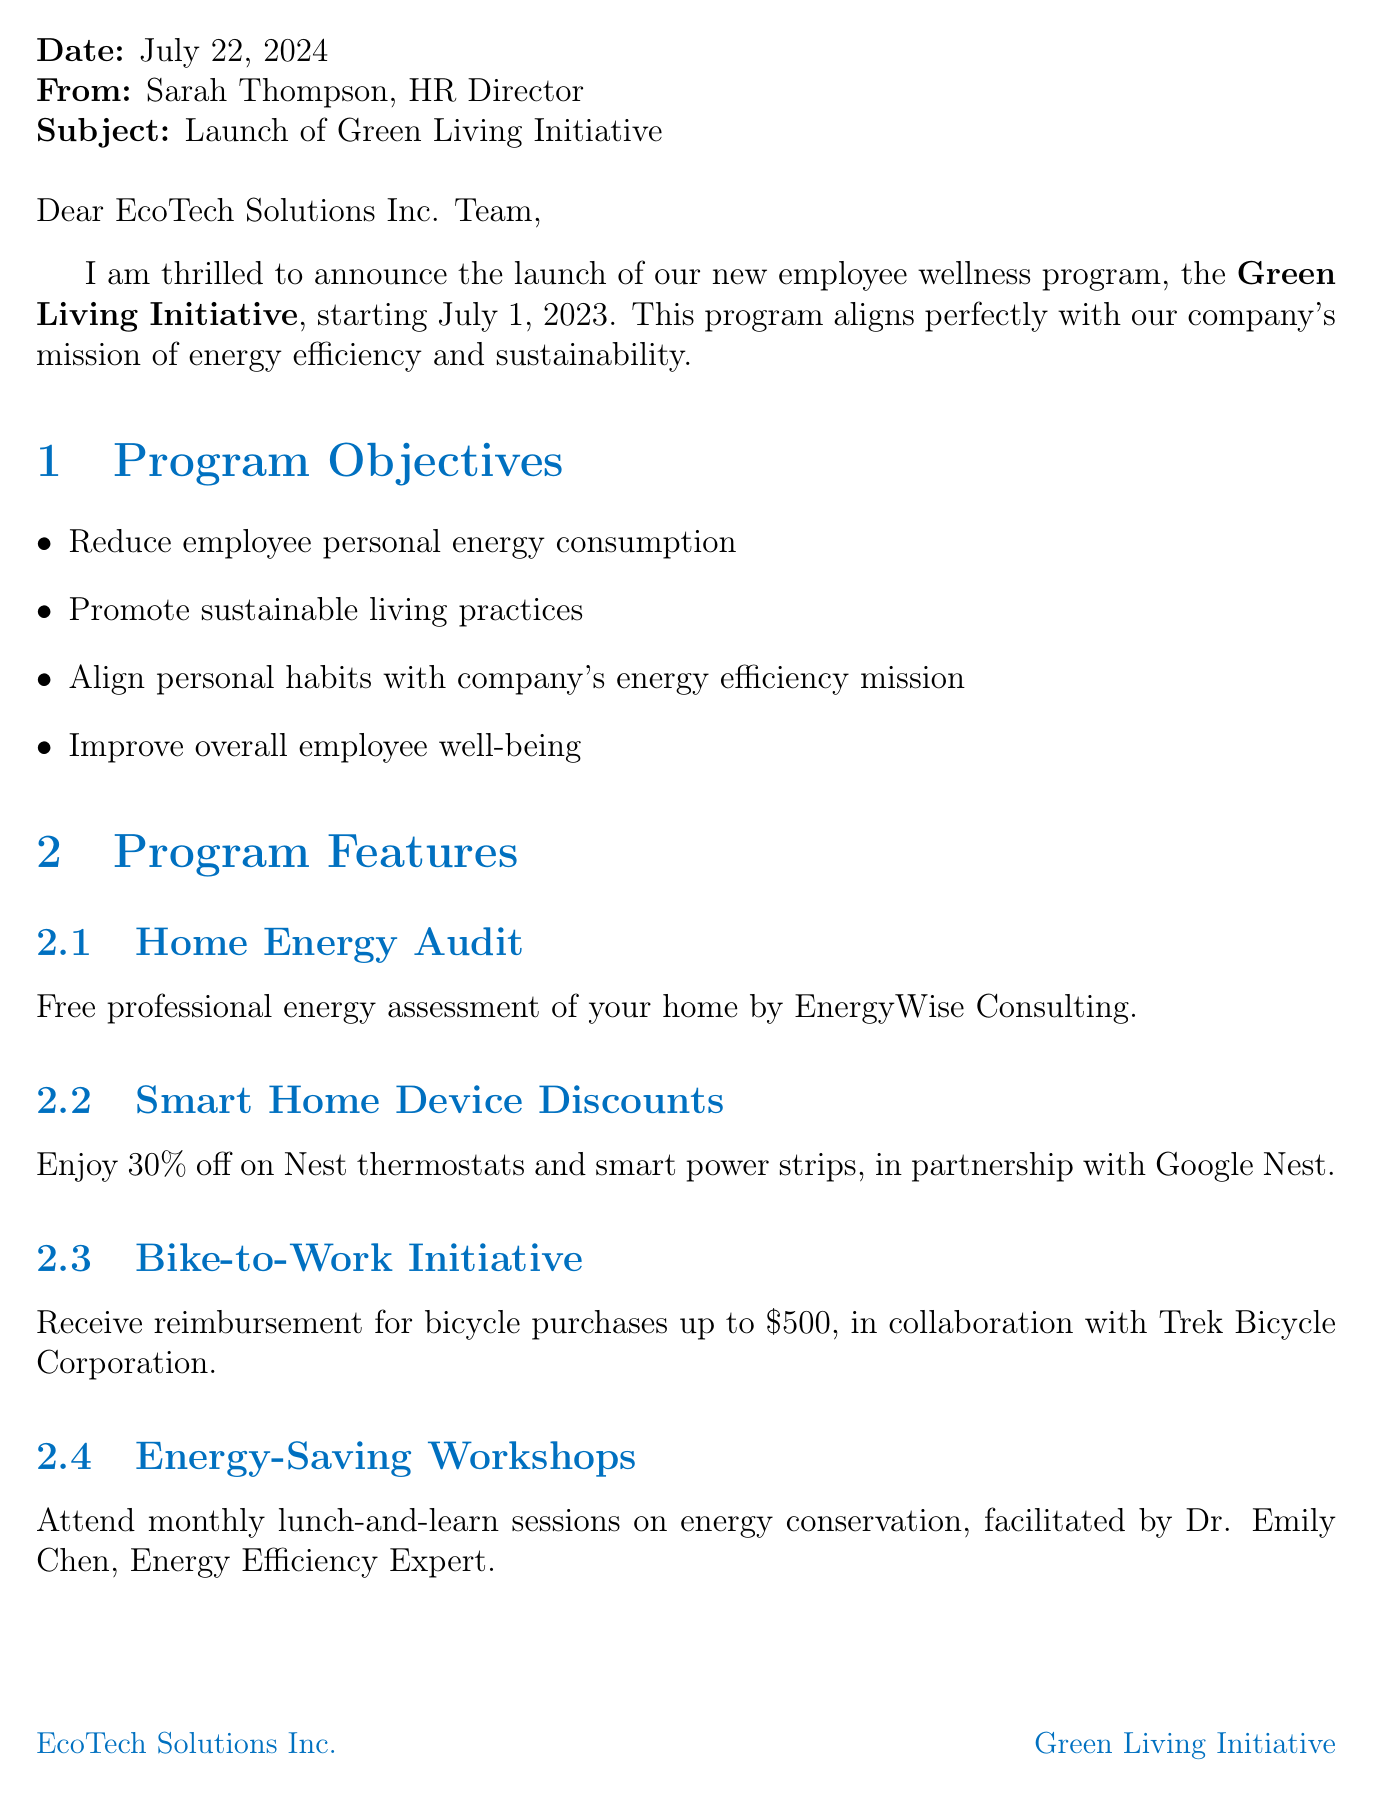What is the name of the new employee wellness program? The name of the program is stated in the subject line and within the text of the document as the Green Living Initiative.
Answer: Green Living Initiative When does the Green Living Initiative start? The start date of the program is mentioned clearly in the overview section of the document.
Answer: July 1, 2023 What is the contact email for enrollment inquiries? The contact email is provided in the enrollment section for any questions related to signing up for the program.
Answer: mark.rodriguez@ecotechsolutions.com What is the reimbursement amount for bicycle purchases under the Bike-to-Work Initiative? The reimbursement amount is listed in the program features section under the Bike-to-Work Initiative.
Answer: $500 What recognition is given to top energy-savers? The document describes a specific recognition given quarterly for the best performers in energy conservation.
Answer: Green Champion Awards How can employees enroll in the Green Living Initiative? The method of enrollment is outlined in the document, specifying the platform through which they can sign up.
Answer: Online portal What is one expected benefit of participating in the program? The expected benefits of the program are listed, and one specific benefit is mentioned in the expected benefits section.
Answer: Reduced personal utility bills Which company provides the Home Energy Audit? The provider for the Home Energy Audit program feature is mentioned directly within the program features section.
Answer: EnergyWise Consulting What are employees encouraged to align their personal habits with? The document specifies an alignment goal for the program related to the company's overall mission.
Answer: Company's energy efficiency mission 